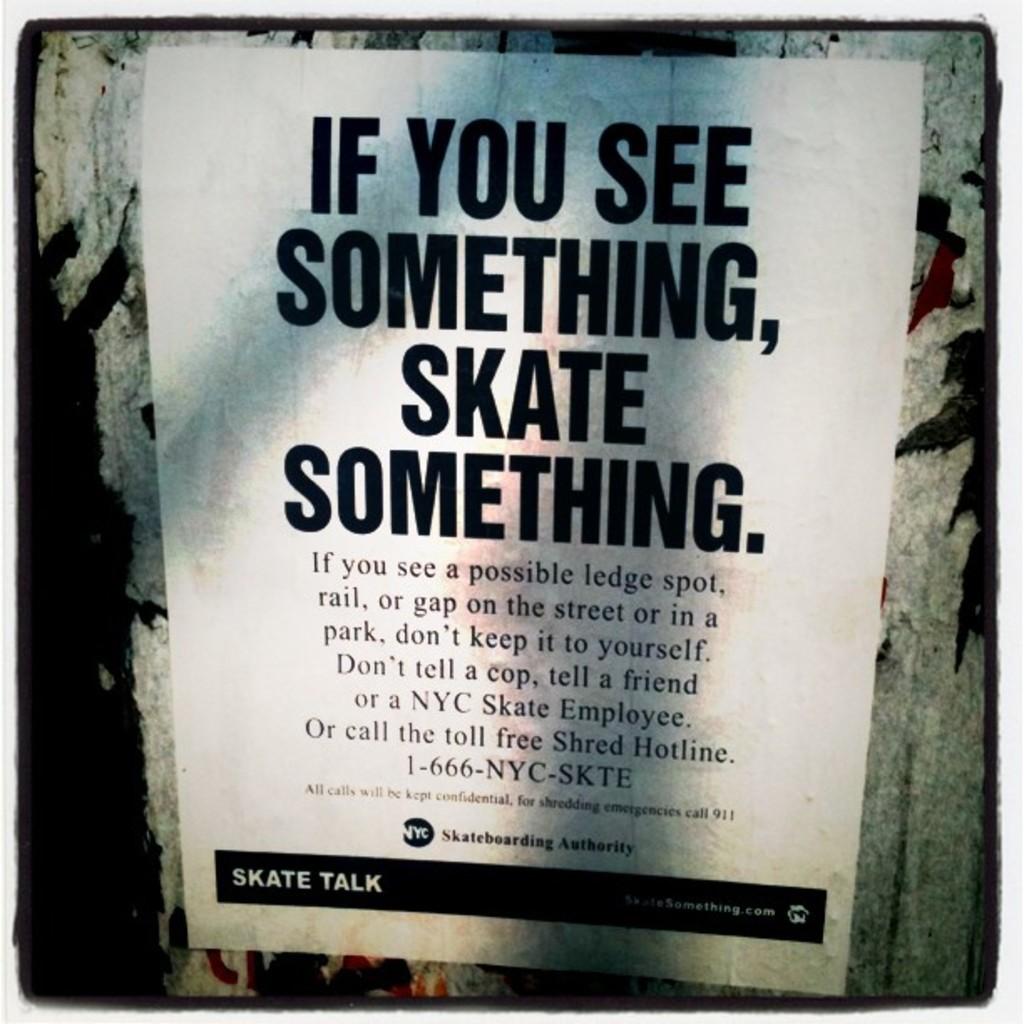What is the phone number?
Your response must be concise. 1-666-nyc-skte. 